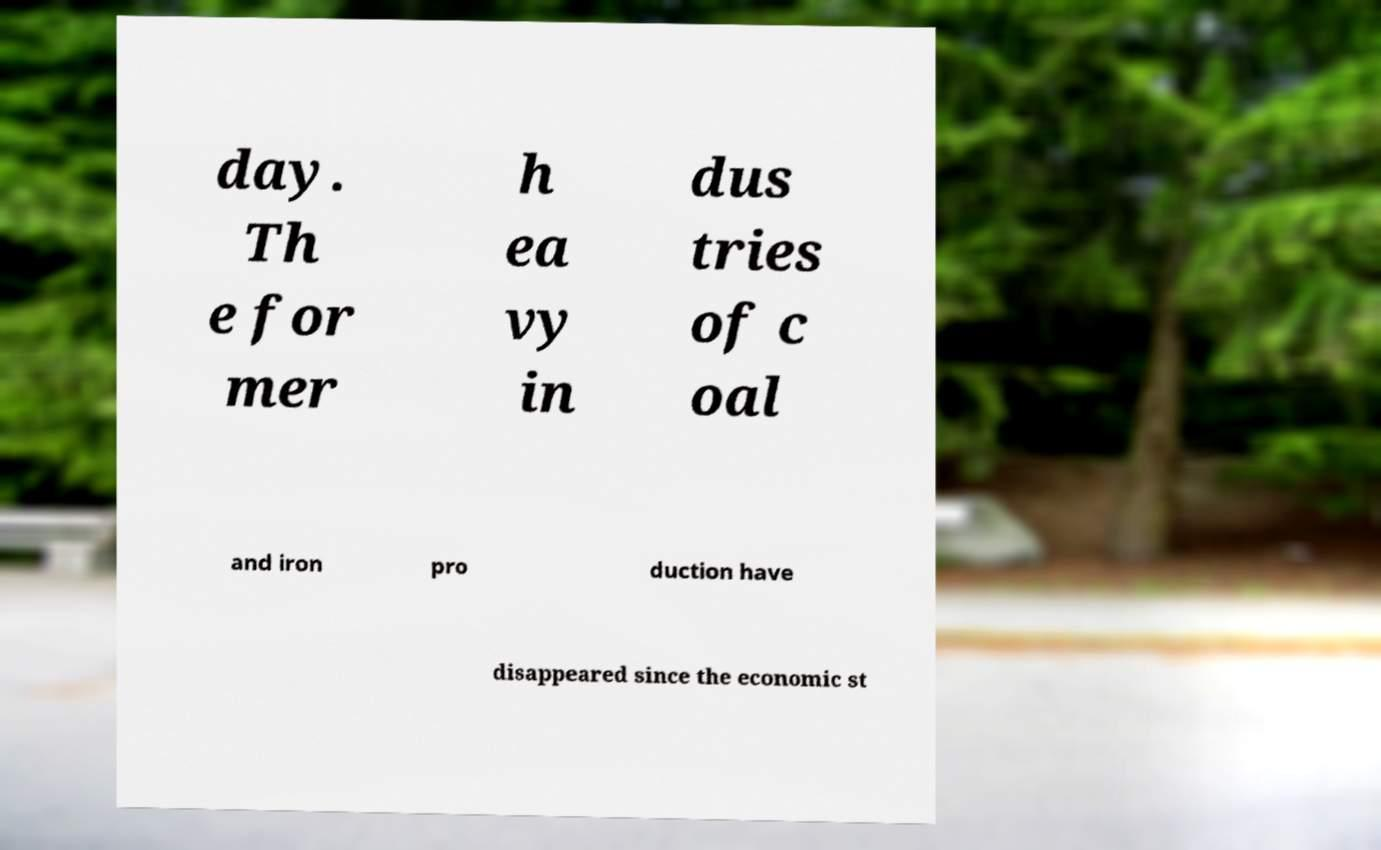Can you accurately transcribe the text from the provided image for me? day. Th e for mer h ea vy in dus tries of c oal and iron pro duction have disappeared since the economic st 